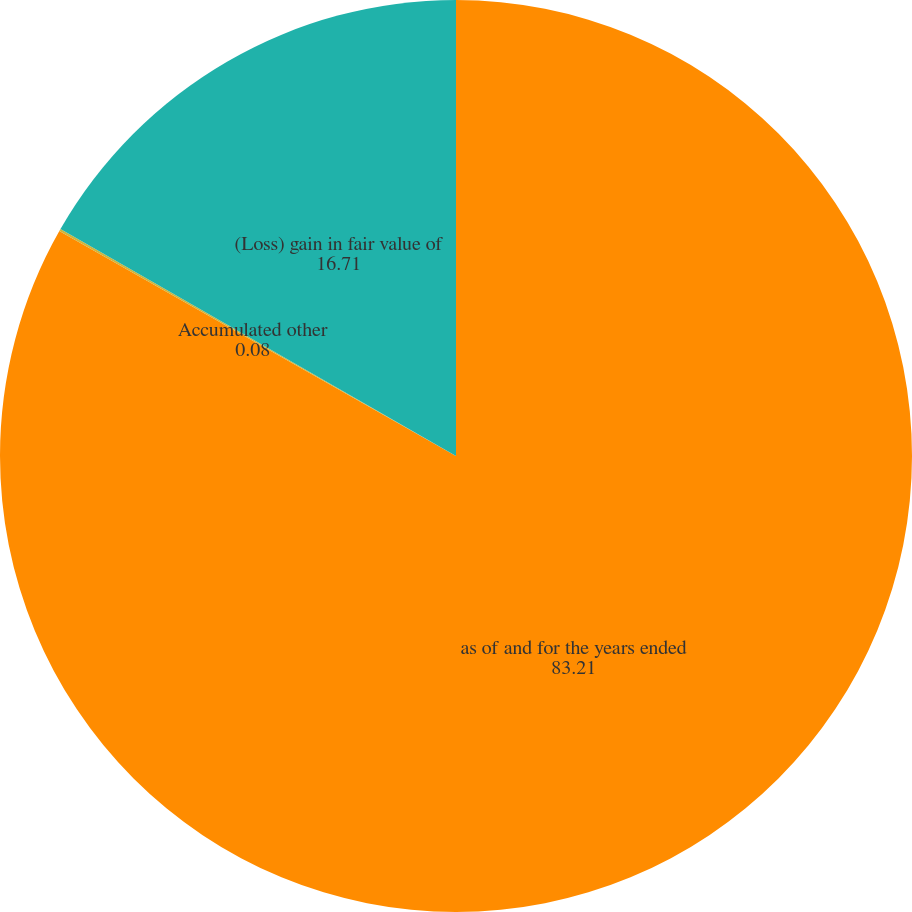Convert chart to OTSL. <chart><loc_0><loc_0><loc_500><loc_500><pie_chart><fcel>as of and for the years ended<fcel>Accumulated other<fcel>(Loss) gain in fair value of<nl><fcel>83.21%<fcel>0.08%<fcel>16.71%<nl></chart> 